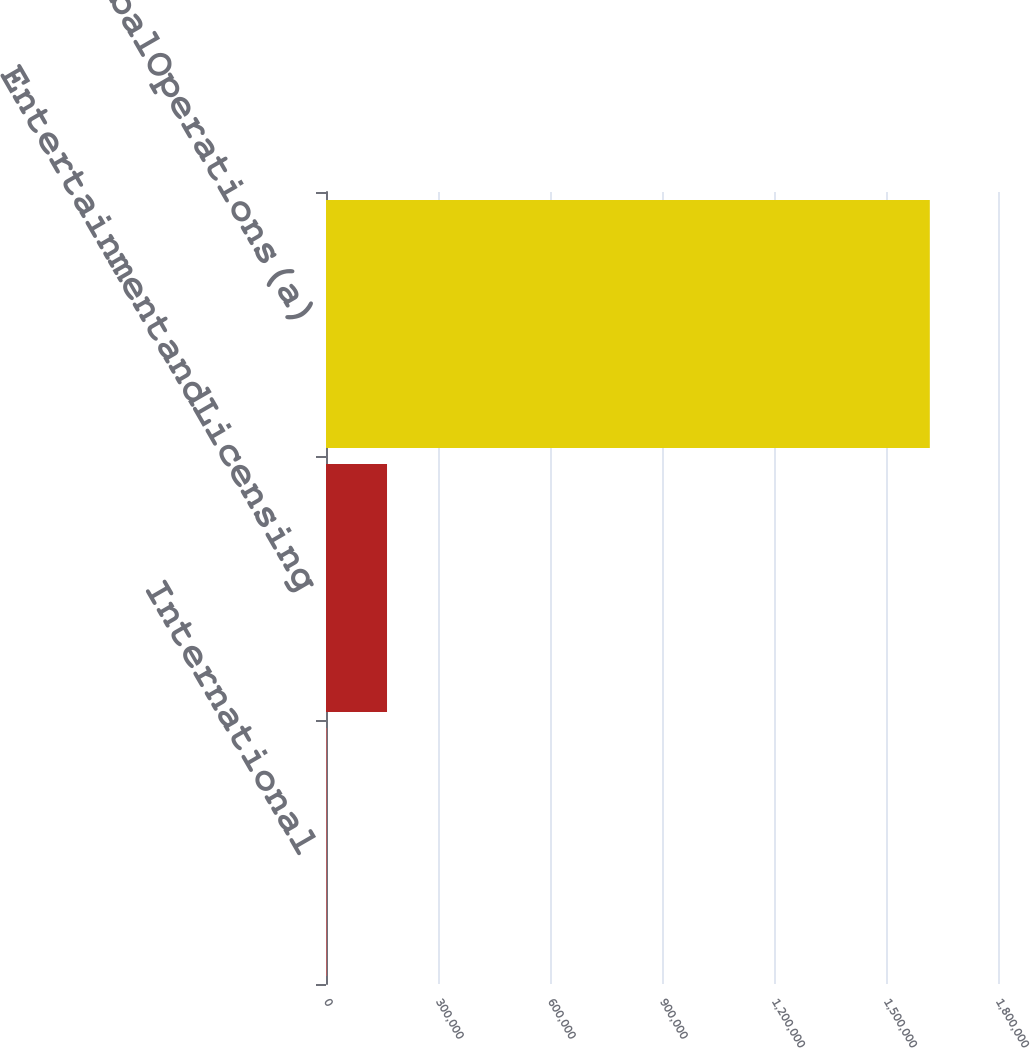Convert chart. <chart><loc_0><loc_0><loc_500><loc_500><bar_chart><fcel>International<fcel>EntertainmentandLicensing<fcel>GlobalOperations(a)<nl><fcel>1908<fcel>163454<fcel>1.61737e+06<nl></chart> 